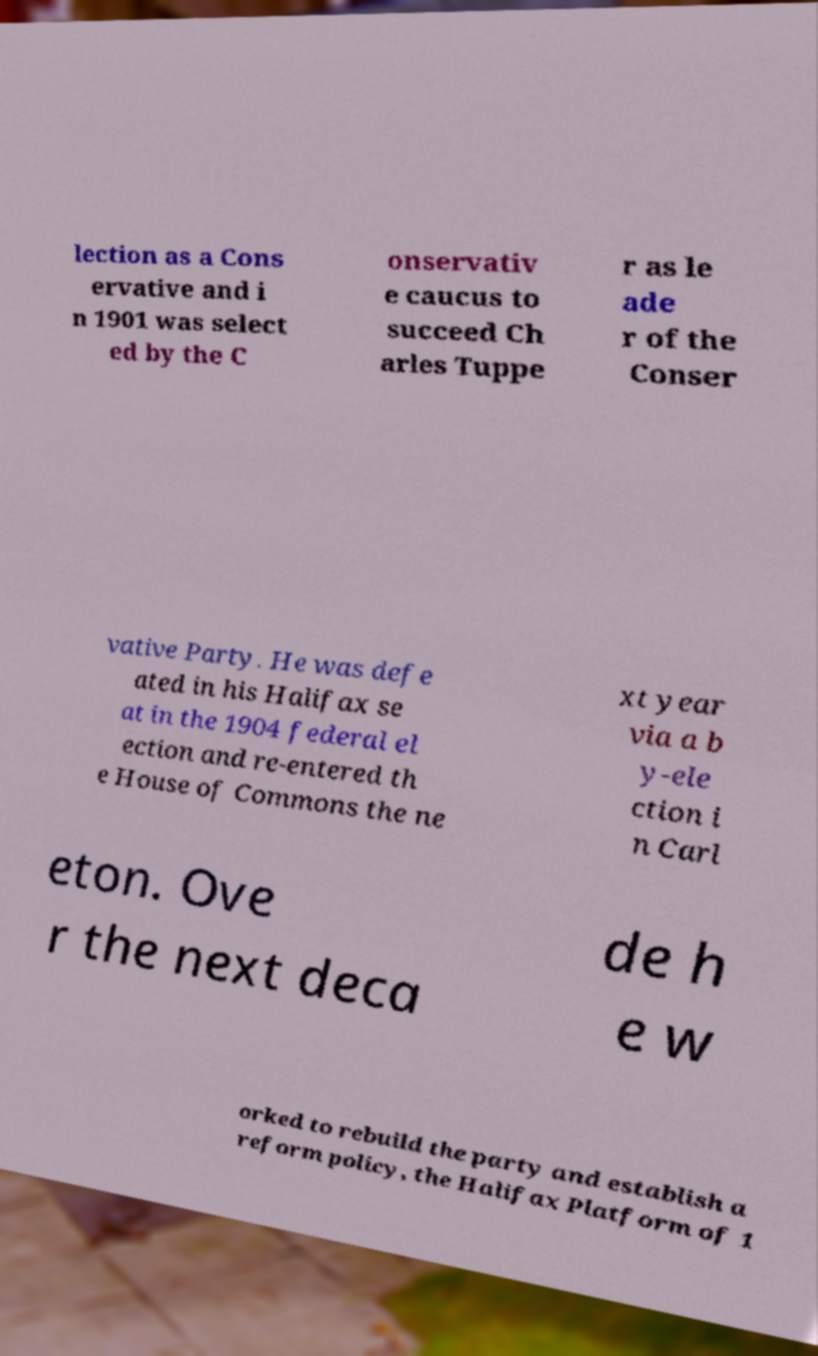What messages or text are displayed in this image? I need them in a readable, typed format. lection as a Cons ervative and i n 1901 was select ed by the C onservativ e caucus to succeed Ch arles Tuppe r as le ade r of the Conser vative Party. He was defe ated in his Halifax se at in the 1904 federal el ection and re-entered th e House of Commons the ne xt year via a b y-ele ction i n Carl eton. Ove r the next deca de h e w orked to rebuild the party and establish a reform policy, the Halifax Platform of 1 